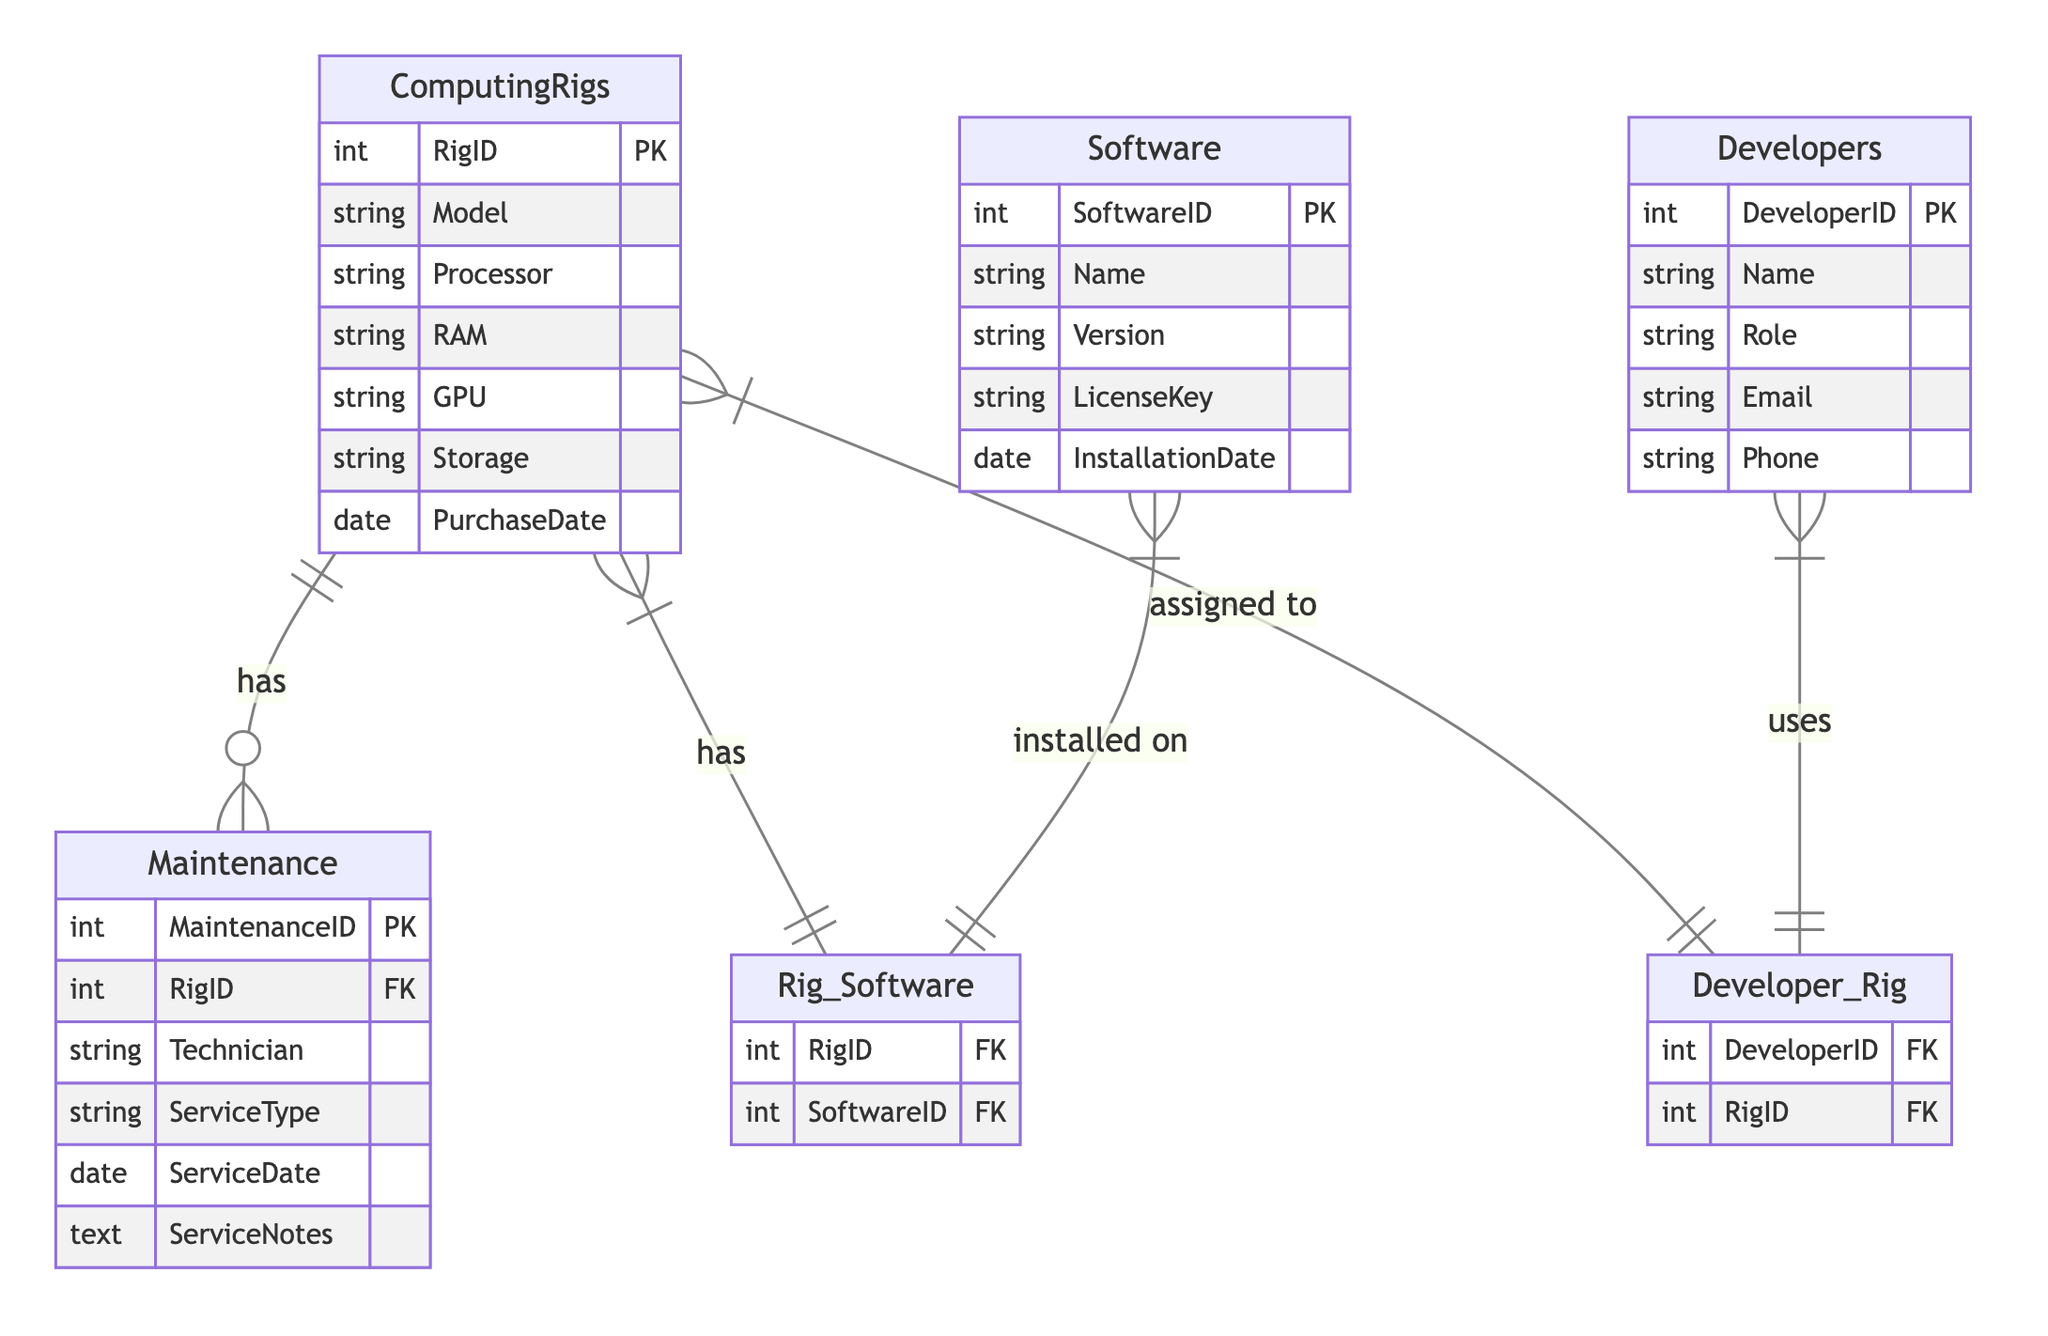What is the primary key of the ComputingRigs? The diagram lists the attributes of the ComputingRigs entity, showing that RigID is marked as the primary key (PK).
Answer: RigID How many entities are present in the diagram? The diagram defines four entities: ComputingRigs, Software, Maintenance, and Developers. By counting these entities, we find the total is 4.
Answer: 4 What type of relationship exists between ComputingRigs and Maintenance? The diagram illustrates a one-to-many relationship (noted as "has") indicating that one ComputingRig can have multiple Maintenance records.
Answer: One-to-Many Which entity has its primary key as SoftwareID? Referring to the attributes in the Software entity section, SoftwareID is shown as its primary key (PK).
Answer: Software What does the relationship "Rig_Software" represent? The relationship "Rig_Software" indicates that there is a many-to-many connection between ComputingRigs and Software, implying that multiple Software programs can be installed on multiple rigs.
Answer: Many-to-Many How many attributes are there for the Developers entity? The Developers entity contains five attributes: DeveloperID, Name, Role, Email, and Phone. By counting these, we find the total is 5 attributes.
Answer: 5 In what way are Developers related to ComputingRigs? The diagram depicts a many-to-many relationship between Developers and ComputingRigs, showing that each Developer can have access to multiple rigs, and each rig can be assigned to multiple developers.
Answer: Many-to-Many What is the attribute type for ServiceDate in the Maintenance entity? The diagram specifies that ServiceDate is listed as a date type under the Maintenance entity attributes.
Answer: Date Which entity is connected to the Maintenance entity? The diagram indicates that the Maintenance entity is connected to the ComputingRigs entity through a one-to-many relationship, meaning each rig can have several maintenance records associated with it.
Answer: ComputingRigs 